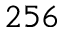Convert formula to latex. <formula><loc_0><loc_0><loc_500><loc_500>2 5 6</formula> 